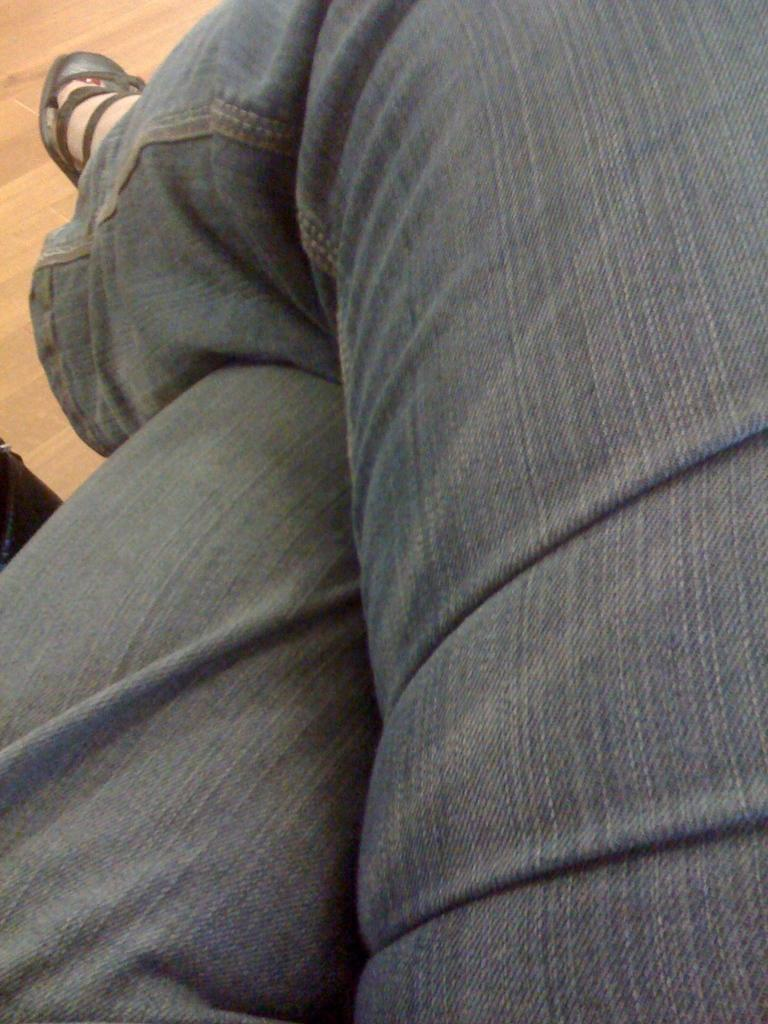What part of a person can be seen in the image? There are legs of a person visible in the image. What type of footwear is the person wearing? The person is wearing black sandals. What type of clothing is the person wearing on their legs? The person is wearing jeans. What color is the person's hair in the image? There is no hair visible in the image; only the person's legs, black sandals, and jeans are present. 